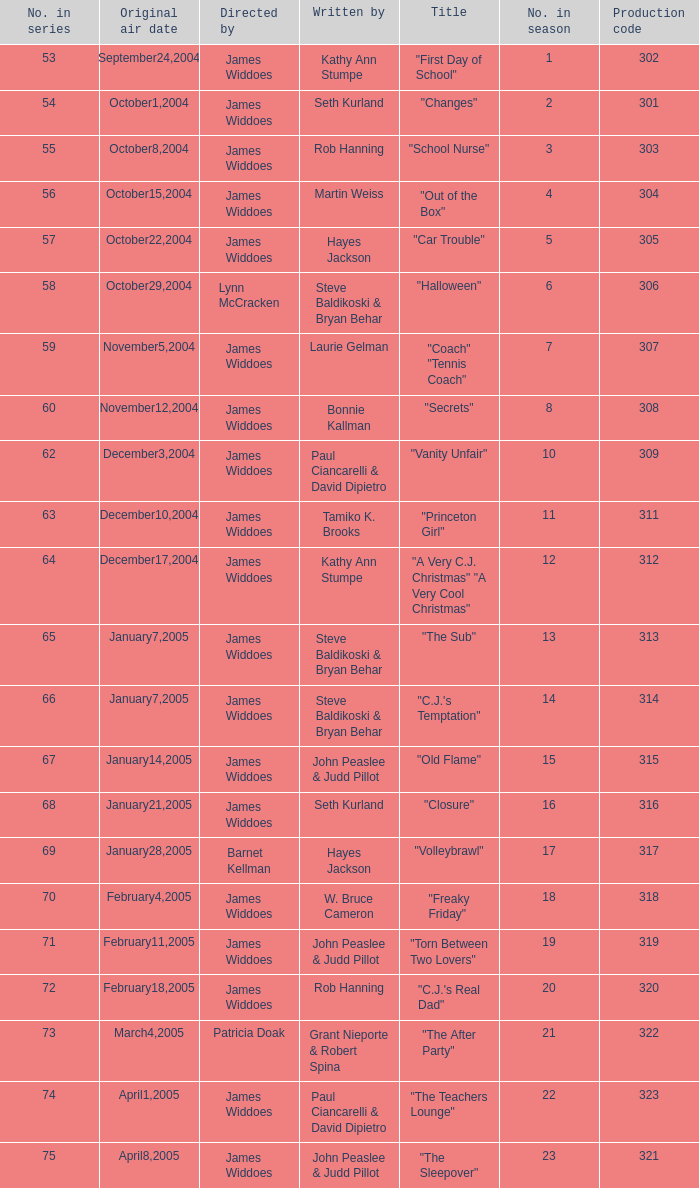How many production codes are there for "the sub"? 1.0. 